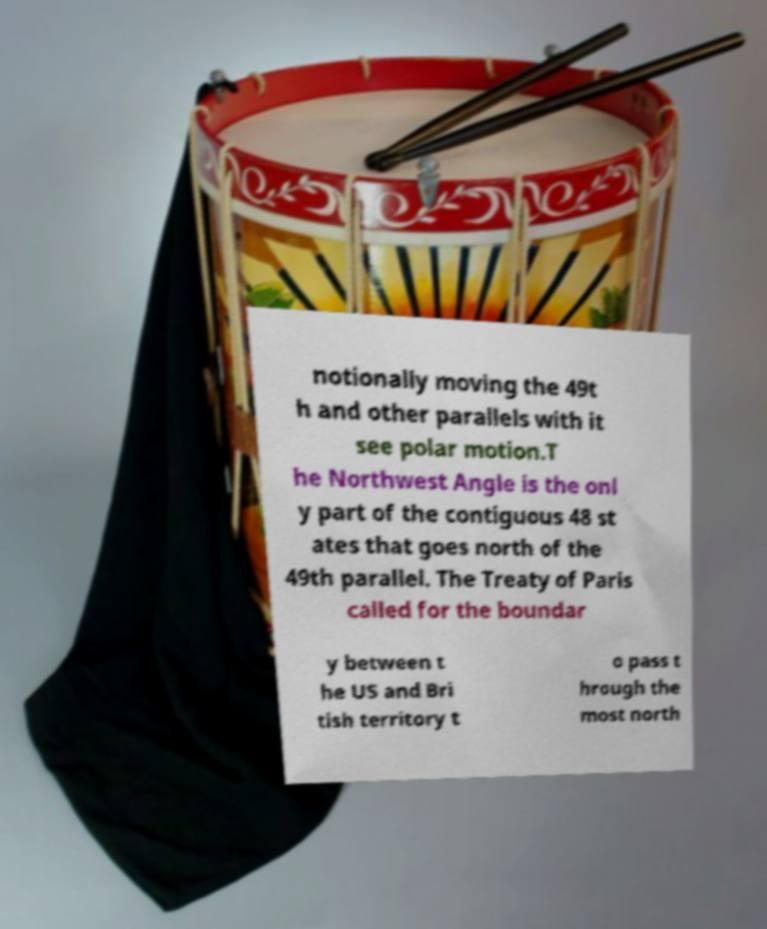Can you read and provide the text displayed in the image?This photo seems to have some interesting text. Can you extract and type it out for me? notionally moving the 49t h and other parallels with it see polar motion.T he Northwest Angle is the onl y part of the contiguous 48 st ates that goes north of the 49th parallel. The Treaty of Paris called for the boundar y between t he US and Bri tish territory t o pass t hrough the most north 